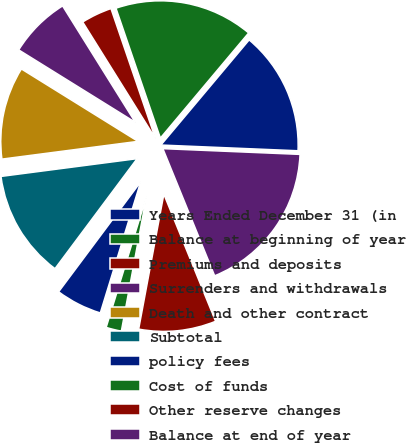<chart> <loc_0><loc_0><loc_500><loc_500><pie_chart><fcel>Years Ended December 31 (in<fcel>Balance at beginning of year<fcel>Premiums and deposits<fcel>Surrenders and withdrawals<fcel>Death and other contract<fcel>Subtotal<fcel>policy fees<fcel>Cost of funds<fcel>Other reserve changes<fcel>Balance at end of year<nl><fcel>14.55%<fcel>16.36%<fcel>3.64%<fcel>7.27%<fcel>10.91%<fcel>12.73%<fcel>5.45%<fcel>1.82%<fcel>9.09%<fcel>18.18%<nl></chart> 